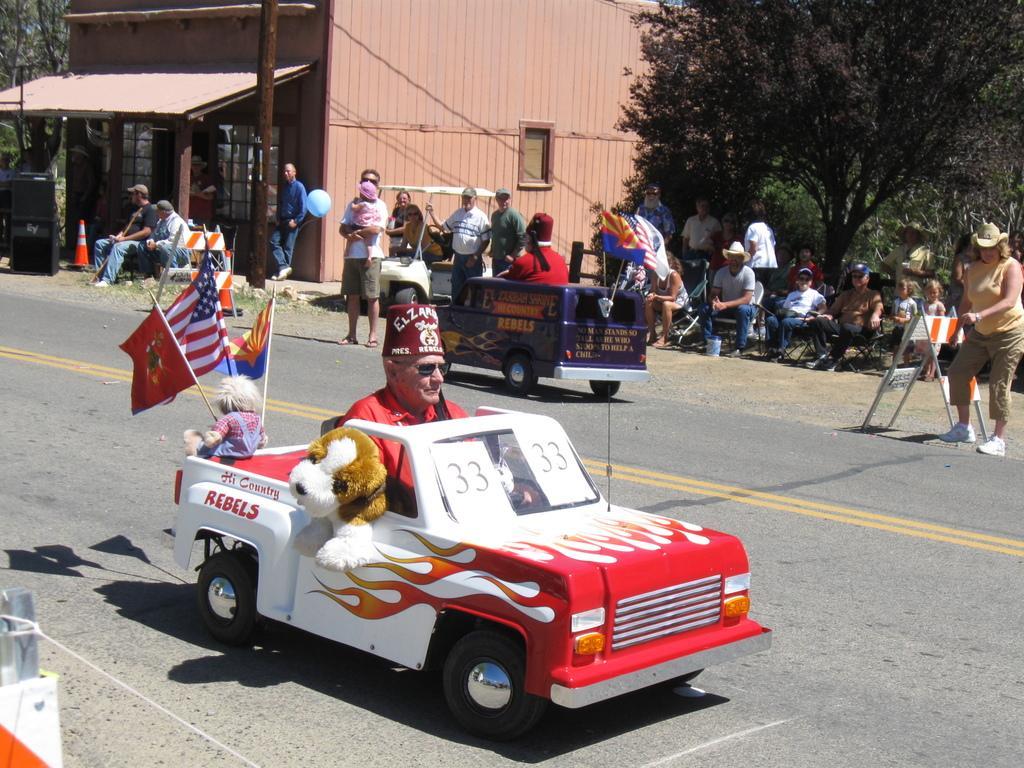Describe this image in one or two sentences. The man in the middle of the picture wearing a red T-shirt is riding a red car. Behind him, we see a doll and flags which are in blue, white, red and yellow color. Beside that, we see people standing. There are people sitting on the chairs. The woman on the right corner of the picture wearing a yellow T-shirt is holding a white board. There are trees and a building in brown color. It is a sunny day. 